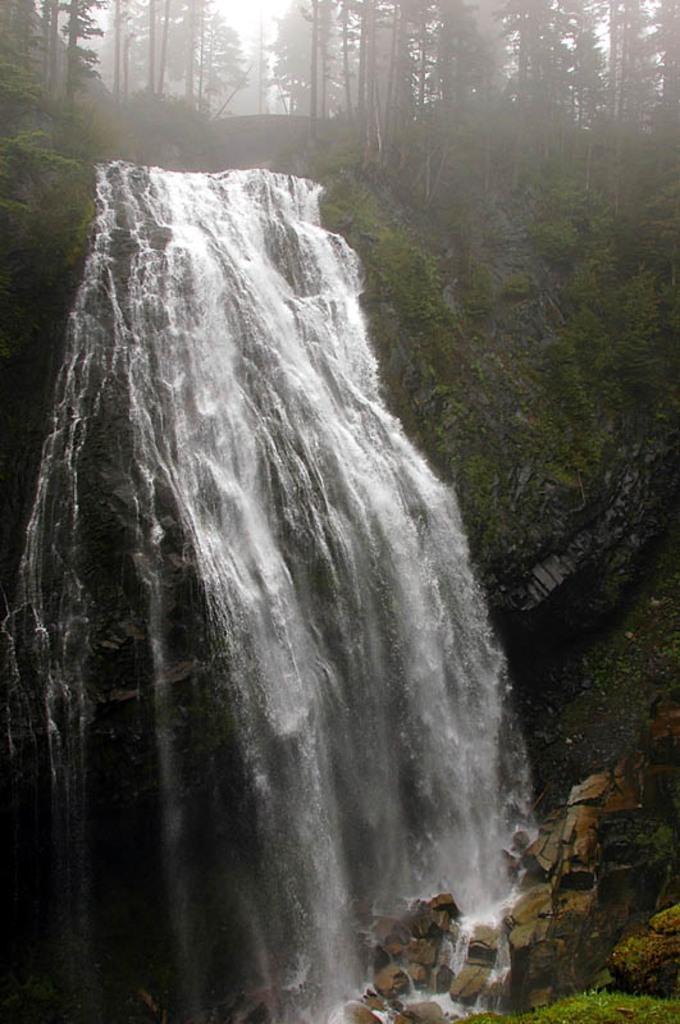Could you give a brief overview of what you see in this image? In this image I can see a waterfall,few rocks and few trees. 